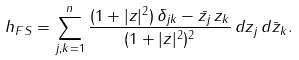<formula> <loc_0><loc_0><loc_500><loc_500>h _ { F S } = \sum _ { j , k = 1 } ^ { n } \frac { ( 1 + | z | ^ { 2 } ) \, \delta _ { j k } - \bar { z _ { j } } \, z _ { k } } { ( 1 + | z | ^ { 2 } ) ^ { 2 } } \, d z _ { j } \, d \bar { z } _ { k } .</formula> 